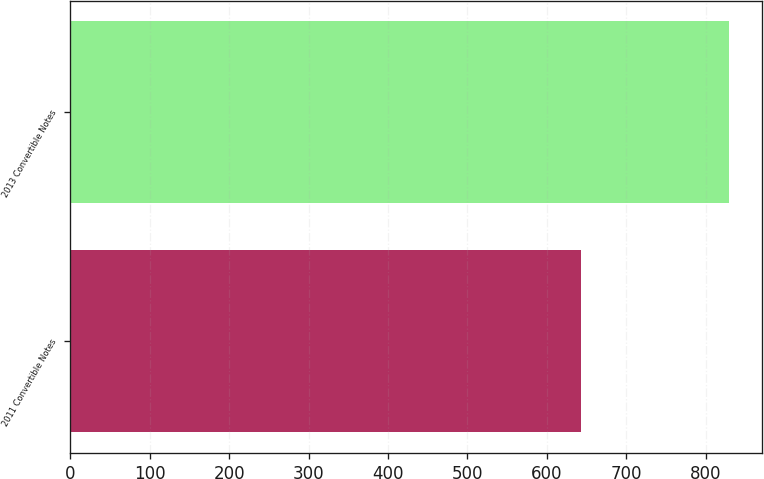Convert chart to OTSL. <chart><loc_0><loc_0><loc_500><loc_500><bar_chart><fcel>2011 Convertible Notes<fcel>2013 Convertible Notes<nl><fcel>643<fcel>829<nl></chart> 